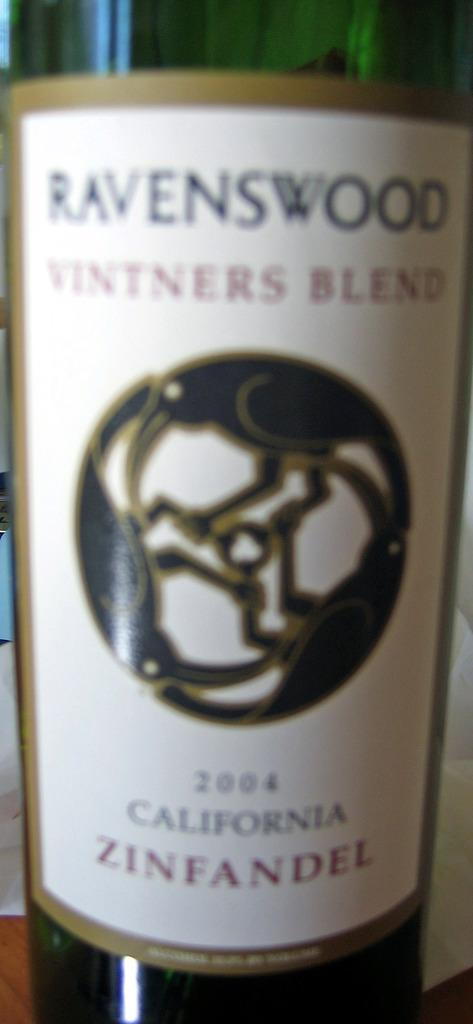<image>
Create a compact narrative representing the image presented. A bottle of Ravenswood vintners blend Zinfandel from 2004. 